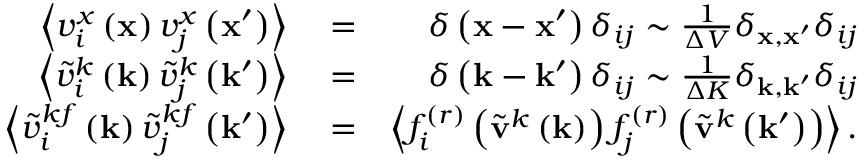<formula> <loc_0><loc_0><loc_500><loc_500>\begin{array} { r l r } { \left \langle v _ { i } ^ { x } \left ( x \right ) v _ { j } ^ { x } \left ( x ^ { \prime } \right ) \right \rangle } & = } & { \delta \left ( x - x ^ { \prime } \right ) \delta _ { i j } \sim \frac { 1 } { \Delta V } \delta _ { x , x ^ { \prime } } \delta _ { i j } } \\ { \left \langle \tilde { v } _ { i } ^ { k } \left ( k \right ) \tilde { v } _ { j } ^ { k } \left ( k ^ { \prime } \right ) \right \rangle } & = } & { \delta \left ( k - k ^ { \prime } \right ) \delta _ { i j } \sim \frac { 1 } { \Delta K } \delta _ { k , k ^ { \prime } } \delta _ { i j } } \\ { \left \langle \tilde { v } _ { i } ^ { k f } \left ( k \right ) \tilde { v } _ { j } ^ { k f } \left ( k ^ { \prime } \right ) \right \rangle } & = } & { \left \langle f _ { i } ^ { ( r ) } \left ( \tilde { v } ^ { k } \left ( k \right ) \right ) f _ { j } ^ { ( r ) } \left ( \tilde { v } ^ { k } \left ( k ^ { \prime } \right ) \right ) \right \rangle . } \end{array}</formula> 